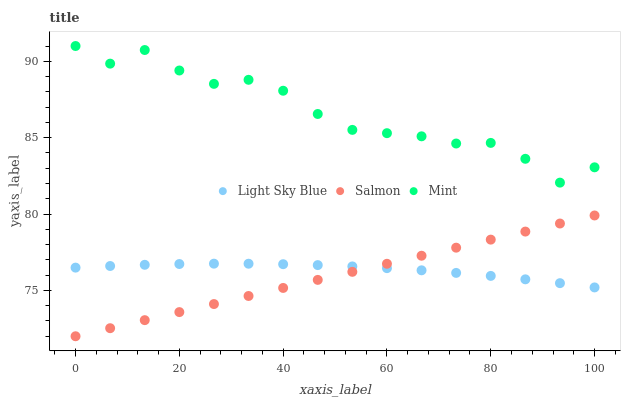Does Salmon have the minimum area under the curve?
Answer yes or no. Yes. Does Mint have the maximum area under the curve?
Answer yes or no. Yes. Does Light Sky Blue have the minimum area under the curve?
Answer yes or no. No. Does Light Sky Blue have the maximum area under the curve?
Answer yes or no. No. Is Salmon the smoothest?
Answer yes or no. Yes. Is Mint the roughest?
Answer yes or no. Yes. Is Light Sky Blue the smoothest?
Answer yes or no. No. Is Light Sky Blue the roughest?
Answer yes or no. No. Does Salmon have the lowest value?
Answer yes or no. Yes. Does Light Sky Blue have the lowest value?
Answer yes or no. No. Does Mint have the highest value?
Answer yes or no. Yes. Does Salmon have the highest value?
Answer yes or no. No. Is Salmon less than Mint?
Answer yes or no. Yes. Is Mint greater than Light Sky Blue?
Answer yes or no. Yes. Does Light Sky Blue intersect Salmon?
Answer yes or no. Yes. Is Light Sky Blue less than Salmon?
Answer yes or no. No. Is Light Sky Blue greater than Salmon?
Answer yes or no. No. Does Salmon intersect Mint?
Answer yes or no. No. 